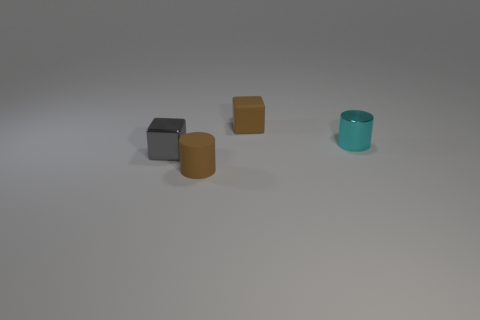Subtract 1 cylinders. How many cylinders are left? 1 Subtract all purple cylinders. Subtract all brown balls. How many cylinders are left? 2 Subtract all brown blocks. How many cyan cylinders are left? 1 Subtract all tiny matte cylinders. Subtract all tiny blue rubber spheres. How many objects are left? 3 Add 2 brown cylinders. How many brown cylinders are left? 3 Add 4 small brown matte cylinders. How many small brown matte cylinders exist? 5 Add 3 shiny cubes. How many objects exist? 7 Subtract all cyan cylinders. How many cylinders are left? 1 Subtract 0 brown balls. How many objects are left? 4 